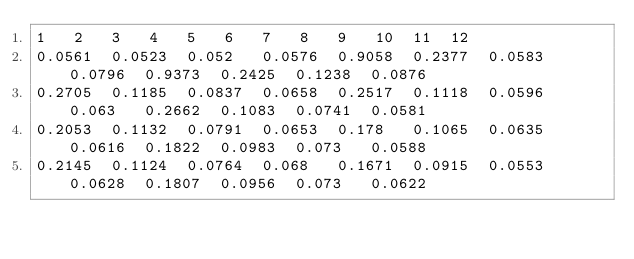Convert code to text. <code><loc_0><loc_0><loc_500><loc_500><_SQL_>1	2	3	4	5	6	7	8	9	10	11	12
0.0561	0.0523	0.052	0.0576	0.9058	0.2377	0.0583	0.0796	0.9373	0.2425	0.1238	0.0876
0.2705	0.1185	0.0837	0.0658	0.2517	0.1118	0.0596	0.063	0.2662	0.1083	0.0741	0.0581
0.2053	0.1132	0.0791	0.0653	0.178	0.1065	0.0635	0.0616	0.1822	0.0983	0.073	0.0588
0.2145	0.1124	0.0764	0.068	0.1671	0.0915	0.0553	0.0628	0.1807	0.0956	0.073	0.0622</code> 